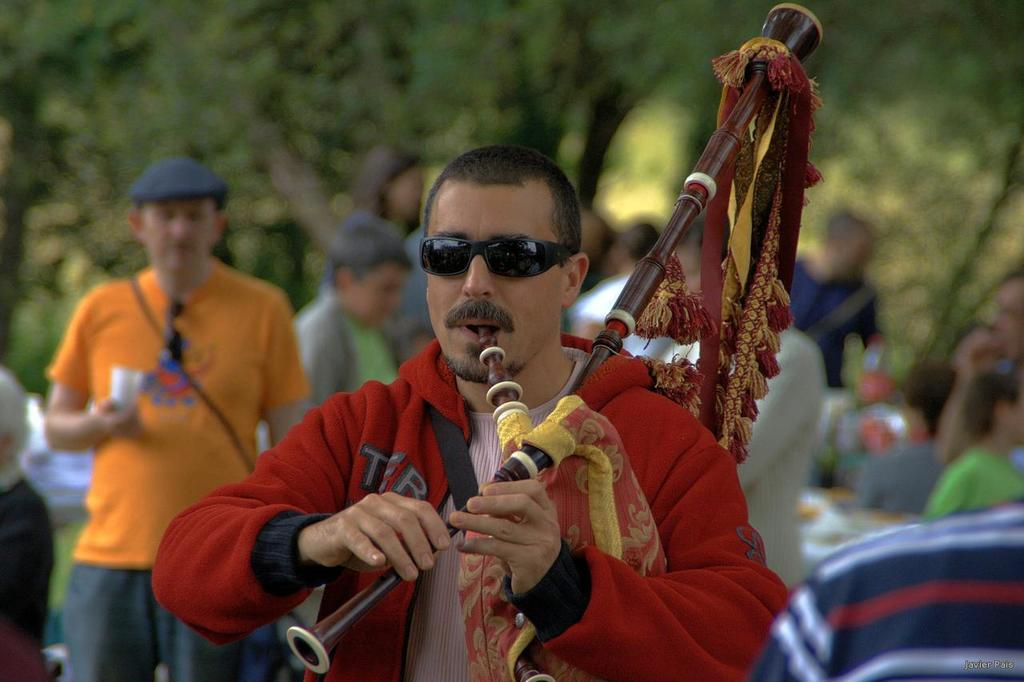What is the man in the image doing? The man is playing a musical instrument in the image. Are there any other people present in the image? Yes, there are people standing behind the man. What type of natural scenery can be seen in the image? There are trees in the image. How would you describe the background of the image? The background of the image is blurred. How many nails are visible on the man's hand in the image? There are no nails visible on the man's hand in the image. What word is being spelled out by the people standing behind the man? There is no indication in the image that the people are spelling out a word. 